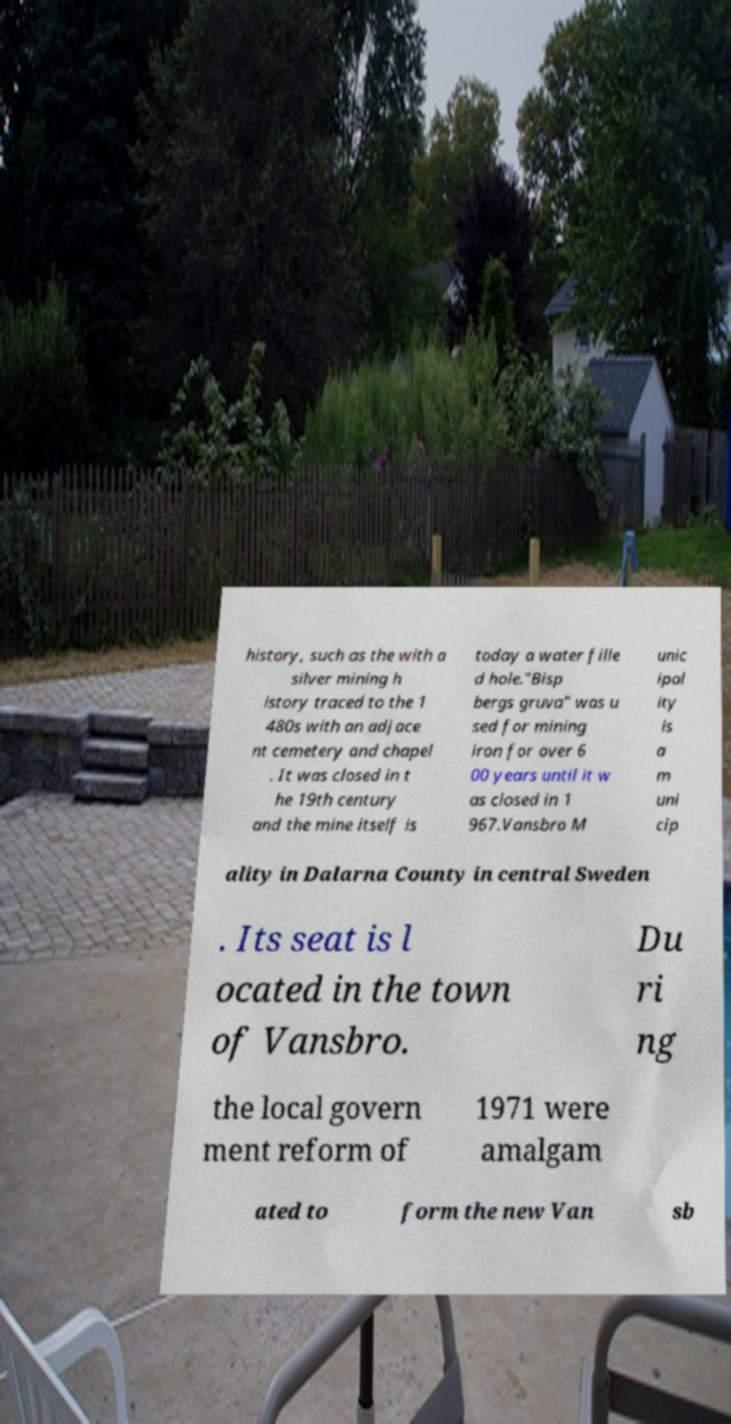What messages or text are displayed in this image? I need them in a readable, typed format. history, such as the with a silver mining h istory traced to the 1 480s with an adjace nt cemetery and chapel . It was closed in t he 19th century and the mine itself is today a water fille d hole."Bisp bergs gruva" was u sed for mining iron for over 6 00 years until it w as closed in 1 967.Vansbro M unic ipal ity is a m uni cip ality in Dalarna County in central Sweden . Its seat is l ocated in the town of Vansbro. Du ri ng the local govern ment reform of 1971 were amalgam ated to form the new Van sb 